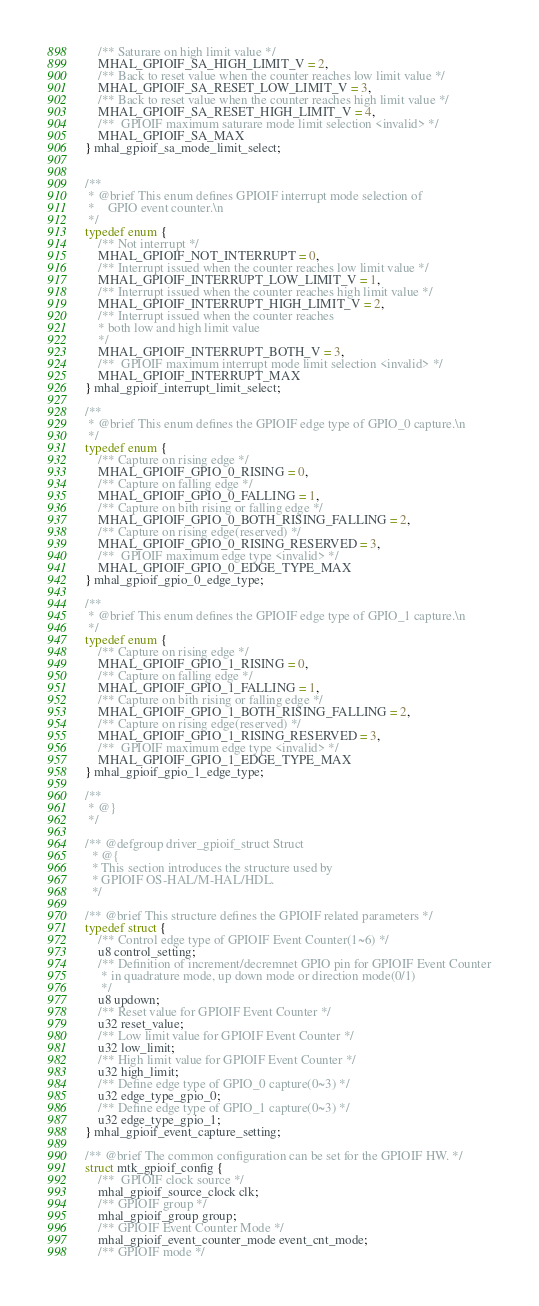<code> <loc_0><loc_0><loc_500><loc_500><_C_>	/** Saturare on high limit value */
	MHAL_GPIOIF_SA_HIGH_LIMIT_V = 2,
	/** Back to reset value when the counter reaches low limit value */
	MHAL_GPIOIF_SA_RESET_LOW_LIMIT_V = 3,
	/** Back to reset value when the counter reaches high limit value */
	MHAL_GPIOIF_SA_RESET_HIGH_LIMIT_V = 4,
	/**  GPIOIF maximum saturare mode limit selection <invalid> */
	MHAL_GPIOIF_SA_MAX
} mhal_gpioif_sa_mode_limit_select;


/**
 * @brief This enum defines GPIOIF interrupt mode selection of
 *    GPIO event counter.\n
 */
typedef enum {
	/** Not interrupt */
	MHAL_GPIOIF_NOT_INTERRUPT = 0,
	/** Interrupt issued when the counter reaches low limit value */
	MHAL_GPIOIF_INTERRUPT_LOW_LIMIT_V = 1,
	/** Interrupt issued when the counter reaches high limit value */
	MHAL_GPIOIF_INTERRUPT_HIGH_LIMIT_V = 2,
	/** Interrupt issued when the counter reaches
	* both low and high limit value
	*/
	MHAL_GPIOIF_INTERRUPT_BOTH_V = 3,
	/**  GPIOIF maximum interrupt mode limit selection <invalid> */
	MHAL_GPIOIF_INTERRUPT_MAX
} mhal_gpioif_interrupt_limit_select;

/**
 * @brief This enum defines the GPIOIF edge type of GPIO_0 capture.\n
 */
typedef enum {
	/** Capture on rising edge */
	MHAL_GPIOIF_GPIO_0_RISING = 0,
	/** Capture on falling edge */
	MHAL_GPIOIF_GPIO_0_FALLING = 1,
	/** Capture on bith rising or falling edge */
	MHAL_GPIOIF_GPIO_0_BOTH_RISING_FALLING = 2,
	/** Capture on rising edge(reserved) */
	MHAL_GPIOIF_GPIO_0_RISING_RESERVED = 3,
	/**  GPIOIF maximum edge type <invalid> */
	MHAL_GPIOIF_GPIO_0_EDGE_TYPE_MAX
} mhal_gpioif_gpio_0_edge_type;

/**
 * @brief This enum defines the GPIOIF edge type of GPIO_1 capture.\n
 */
typedef enum {
	/** Capture on rising edge */
	MHAL_GPIOIF_GPIO_1_RISING = 0,
	/** Capture on falling edge */
	MHAL_GPIOIF_GPIO_1_FALLING = 1,
	/** Capture on bith rising or falling edge */
	MHAL_GPIOIF_GPIO_1_BOTH_RISING_FALLING = 2,
	/** Capture on rising edge(reserved) */
	MHAL_GPIOIF_GPIO_1_RISING_RESERVED = 3,
	/**  GPIOIF maximum edge type <invalid> */
	MHAL_GPIOIF_GPIO_1_EDGE_TYPE_MAX
} mhal_gpioif_gpio_1_edge_type;

/**
 * @}
 */

/** @defgroup driver_gpioif_struct Struct
  * @{
  * This section introduces the structure used by
  * GPIOIF OS-HAL/M-HAL/HDL.
  */

/** @brief This structure defines the GPIOIF related parameters */
typedef struct {
	/** Control edge type of GPIOIF Event Counter(1~6) */
	u8 control_setting;
	/** Definition of increment/decremnet GPIO pin for GPIOIF Event Counter
	 * in quadrature mode, up down mode or direction mode(0/1)
	 */
	u8 updown;
	/** Reset value for GPIOIF Event Counter */
	u32 reset_value;
	/** Low limit value for GPIOIF Event Counter */
	u32 low_limit;
	/** High limit value for GPIOIF Event Counter */
	u32 high_limit;
	/** Define edge type of GPIO_0 capture(0~3) */
	u32 edge_type_gpio_0;
	/** Define edge type of GPIO_1 capture(0~3) */
	u32 edge_type_gpio_1;
} mhal_gpioif_event_capture_setting;

/** @brief The common configuration can be set for the GPIOIF HW. */
struct mtk_gpioif_config {
	/**  GPIOIF clock source */
	mhal_gpioif_source_clock clk;
	/** GPIOIF group */
	mhal_gpioif_group group;
	/** GPIOIF Event Counter Mode */
	mhal_gpioif_event_counter_mode event_cnt_mode;
	/** GPIOIF mode */</code> 